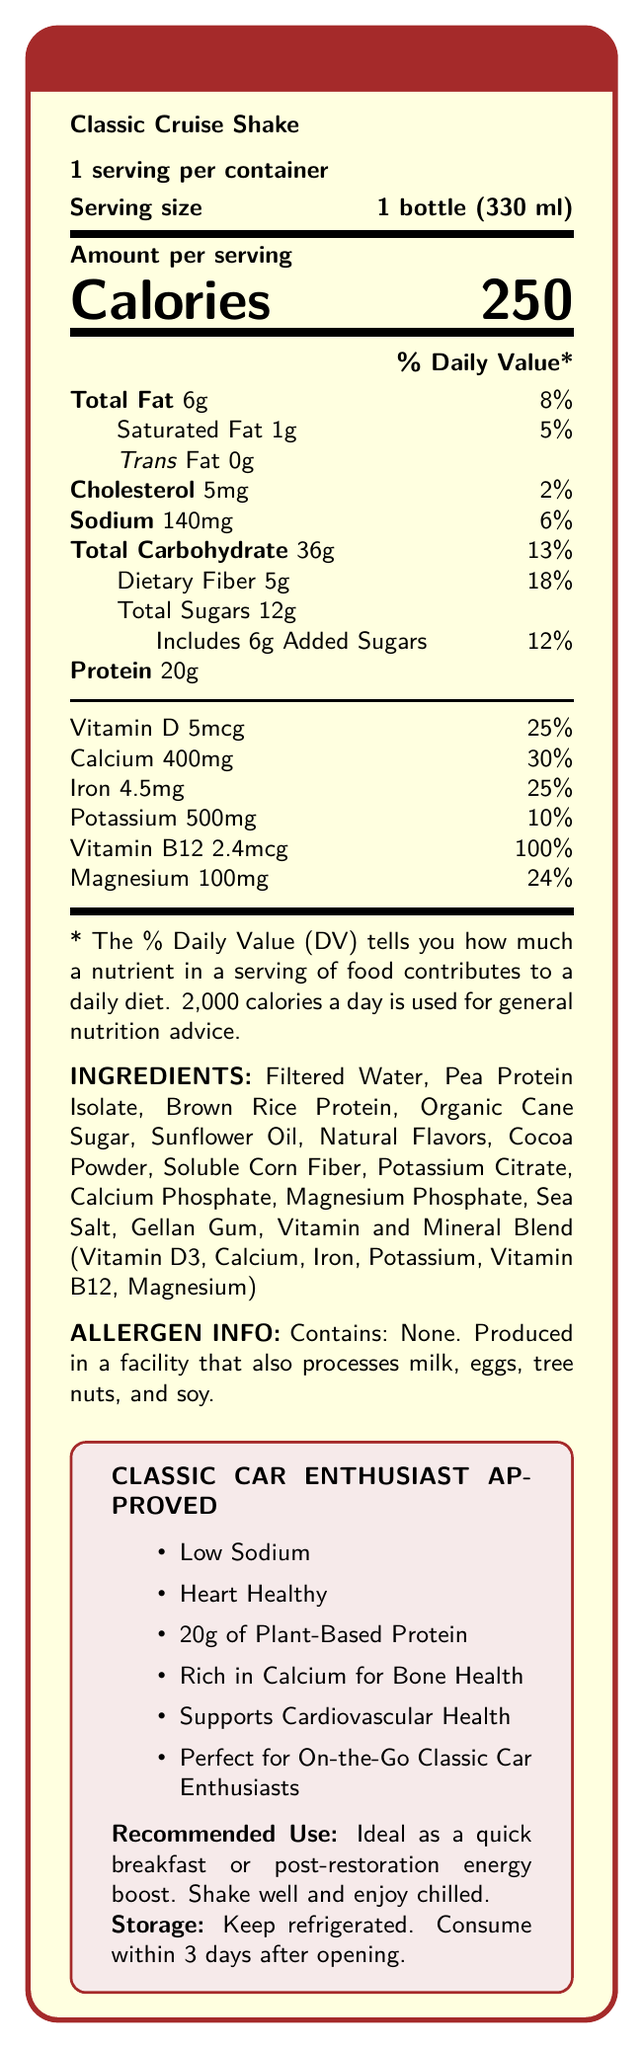what is the product name? The product name is explicitly mentioned at the beginning of the document.
Answer: Classic Cruise Shake how many calories are in one serving? The document clearly states that each serving contains 250 calories.
Answer: 250 how much protein is in one bottle? The document specifies that there are 20 grams of protein in one bottle.
Answer: 20g what is the daily value percentage of calcium in the shake? The document indicates that the shake provides 30% of the daily value for calcium.
Answer: 30% what type of protein is used in the Classic Cruise Shake? The ingredients list includes Pea Protein Isolate and Brown Rice Protein.
Answer: Pea Protein Isolate and Brown Rice Protein which ingredient is the main source of sweetness in the shake? A. Organic Cane Sugar B. Natural Flavors C. Sunflower Oil The ingredients list includes Organic Cane Sugar as the sweetening agent.
Answer: A. Organic Cane Sugar what is the serving size of Classic Cruise Shake? A. 200 ml B. 330 ml C. 400 ml The serving size is listed as 1 bottle (330 ml).
Answer: B. 330 ml does the Classic Cruise Shake contain any trans fat? The document lists trans fat as 0g.
Answer: No how much dietary fiber is in the Classic Cruise Shake? The document indicates that there are 5 grams of dietary fiber in each serving.
Answer: 5g is the Classic Cruise Shake produced in a facility that also processes soy? The allergen information states that it is produced in a facility that also processes milk, eggs, tree nuts, and soy.
Answer: Yes describe the main idea of the document. The document focuses on nutritional values, ingredients, allergen information, and usage recommendations, highlighting the shake’s suitability for classic car enthusiasts.
Answer: The document provides the Nutrition Facts for the Classic Cruise Shake, emphasizing it as a low-sodium, heart-healthy meal replacement shake suitable for on-the-go classic car enthusiasts. It contains 250 calories, 20g of protein, vitamins and minerals, and is produced in a facility that processes various allergens. It includes guidelines for storage and use. how many vitamin D micrograms are in the Classic Cruise Shake? The document specifies that there are 5 micrograms of Vitamin D in each serving.
Answer: 5mcg what is the daily value percentage of magnesium provided by the Classic Cruise Shake? The document states that the shake provides 24% of the daily value for magnesium.
Answer: 24% what are the storage instructions for the Classic Cruise Shake? The storage instructions in the document are clear about refrigeration and consumption timeframe after opening.
Answer: Keep refrigerated. Consume within 3 days after opening. what are the marketing claims associated with Classic Cruise Shake?
     I. Heart Healthy
    II. Gluten-Free
    III. 20g of Plant-Based Protein
    IV. Dairy-Free The marketing claims listed are "Heart Healthy" and "20g of Plant-Based Protein". There is no mention of "Gluten-Free" or "Dairy-Free".
Answer: I and III does the Classic Cruise Shake contain any cholesterol? The document lists 5mg of cholesterol per serving.
Answer: Yes how does the shake support cardiovascular health? The marketing claims specifically state that the shake is low in sodium and supports cardiovascular health.
Answer: It is low in sodium and heart-healthy. 